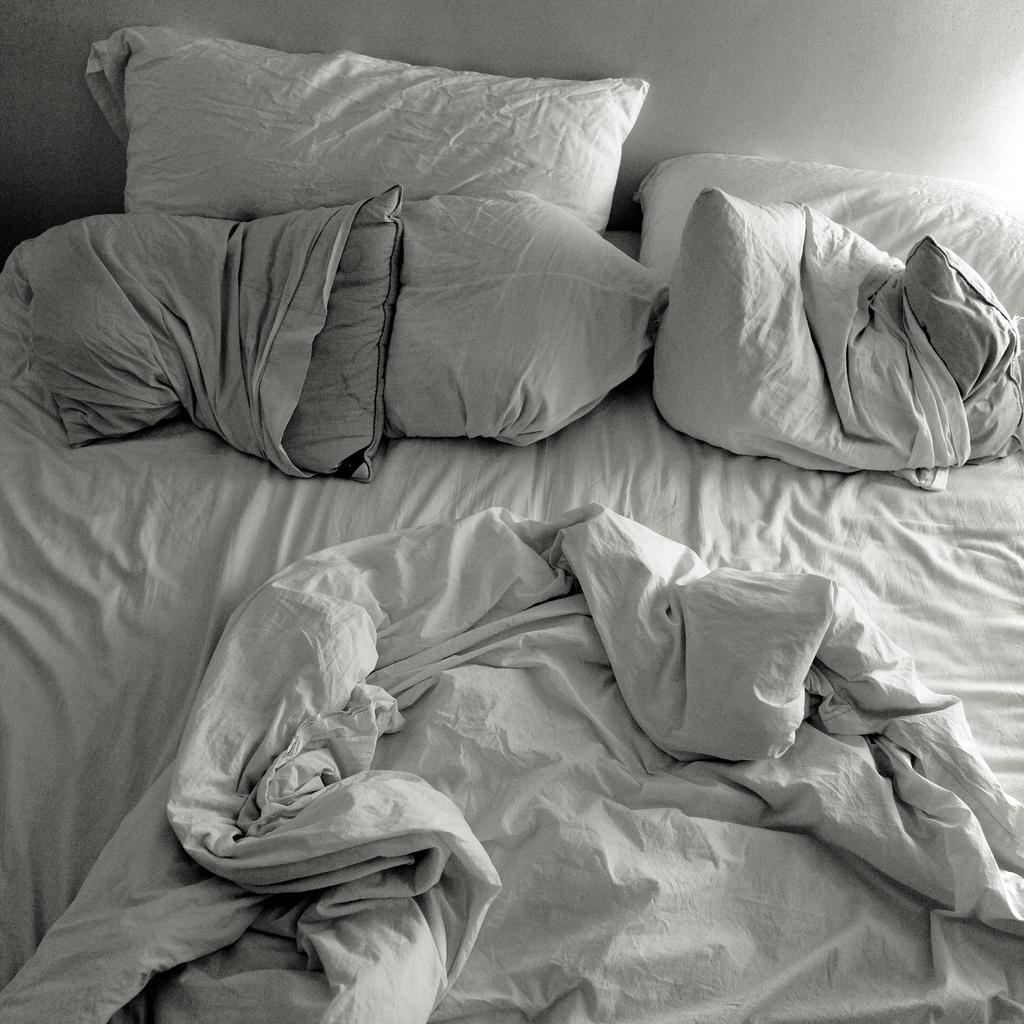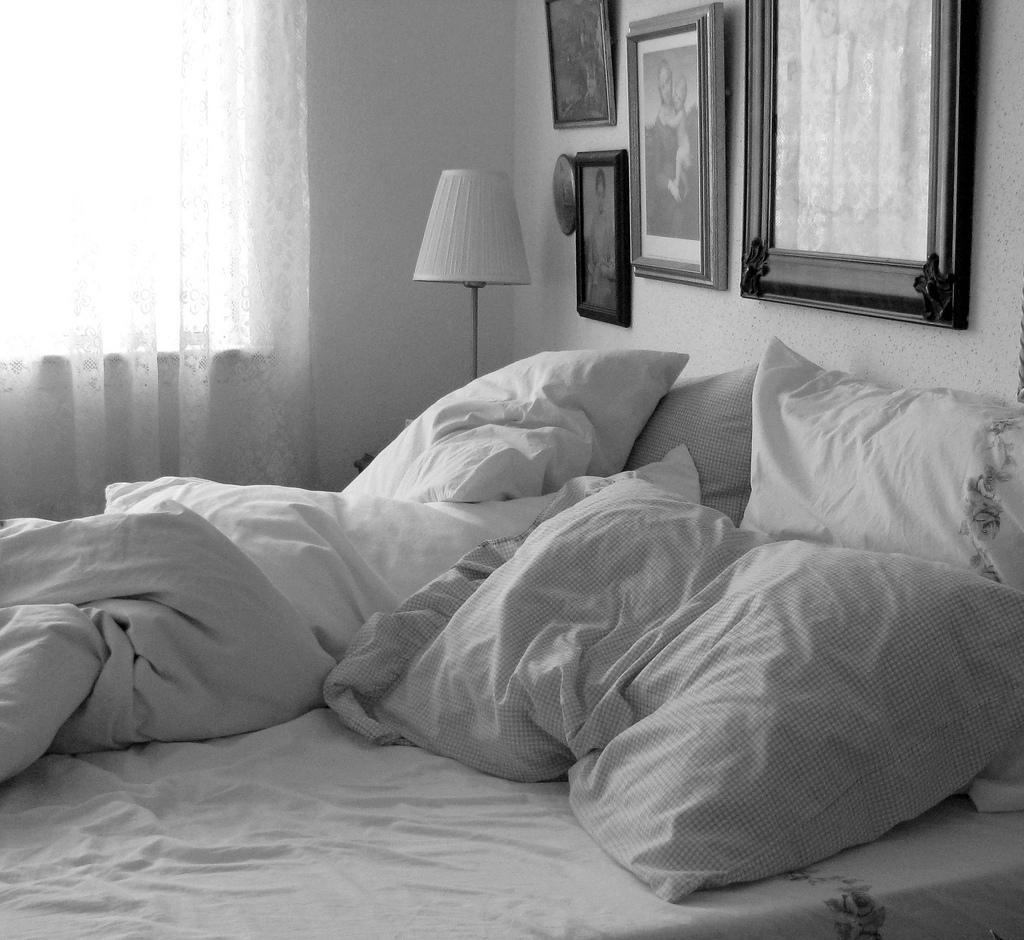The first image is the image on the left, the second image is the image on the right. For the images shown, is this caption "there is a table lamp on the right image" true? Answer yes or no. Yes. 